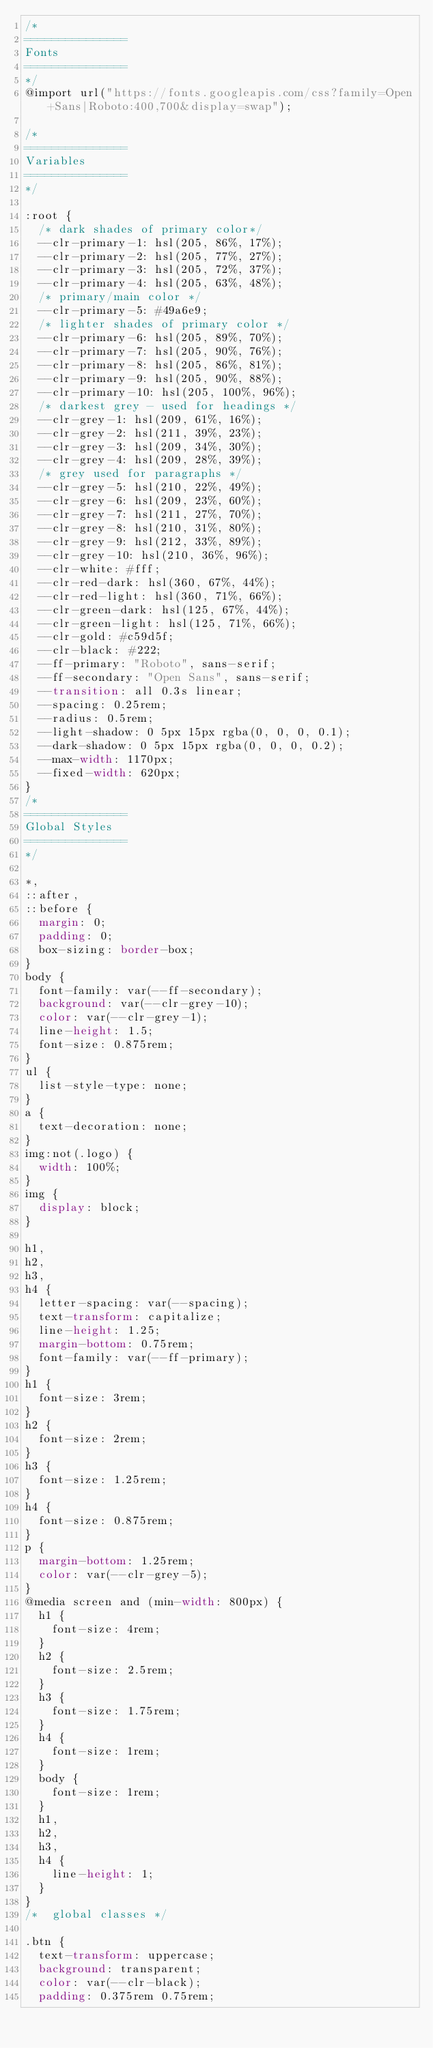Convert code to text. <code><loc_0><loc_0><loc_500><loc_500><_CSS_>/*
=============== 
Fonts
===============
*/
@import url("https://fonts.googleapis.com/css?family=Open+Sans|Roboto:400,700&display=swap");

/*
=============== 
Variables
===============
*/

:root {
  /* dark shades of primary color*/
  --clr-primary-1: hsl(205, 86%, 17%);
  --clr-primary-2: hsl(205, 77%, 27%);
  --clr-primary-3: hsl(205, 72%, 37%);
  --clr-primary-4: hsl(205, 63%, 48%);
  /* primary/main color */
  --clr-primary-5: #49a6e9;
  /* lighter shades of primary color */
  --clr-primary-6: hsl(205, 89%, 70%);
  --clr-primary-7: hsl(205, 90%, 76%);
  --clr-primary-8: hsl(205, 86%, 81%);
  --clr-primary-9: hsl(205, 90%, 88%);
  --clr-primary-10: hsl(205, 100%, 96%);
  /* darkest grey - used for headings */
  --clr-grey-1: hsl(209, 61%, 16%);
  --clr-grey-2: hsl(211, 39%, 23%);
  --clr-grey-3: hsl(209, 34%, 30%);
  --clr-grey-4: hsl(209, 28%, 39%);
  /* grey used for paragraphs */
  --clr-grey-5: hsl(210, 22%, 49%);
  --clr-grey-6: hsl(209, 23%, 60%);
  --clr-grey-7: hsl(211, 27%, 70%);
  --clr-grey-8: hsl(210, 31%, 80%);
  --clr-grey-9: hsl(212, 33%, 89%);
  --clr-grey-10: hsl(210, 36%, 96%);
  --clr-white: #fff;
  --clr-red-dark: hsl(360, 67%, 44%);
  --clr-red-light: hsl(360, 71%, 66%);
  --clr-green-dark: hsl(125, 67%, 44%);
  --clr-green-light: hsl(125, 71%, 66%);
  --clr-gold: #c59d5f;
  --clr-black: #222;
  --ff-primary: "Roboto", sans-serif;
  --ff-secondary: "Open Sans", sans-serif;
  --transition: all 0.3s linear;
  --spacing: 0.25rem;
  --radius: 0.5rem;
  --light-shadow: 0 5px 15px rgba(0, 0, 0, 0.1);
  --dark-shadow: 0 5px 15px rgba(0, 0, 0, 0.2);
  --max-width: 1170px;
  --fixed-width: 620px;
}
/*
=============== 
Global Styles
===============
*/

*,
::after,
::before {
  margin: 0;
  padding: 0;
  box-sizing: border-box;
}
body {
  font-family: var(--ff-secondary);
  background: var(--clr-grey-10);
  color: var(--clr-grey-1);
  line-height: 1.5;
  font-size: 0.875rem;
}
ul {
  list-style-type: none;
}
a {
  text-decoration: none;
}
img:not(.logo) {
  width: 100%;
}
img {
  display: block;
}

h1,
h2,
h3,
h4 {
  letter-spacing: var(--spacing);
  text-transform: capitalize;
  line-height: 1.25;
  margin-bottom: 0.75rem;
  font-family: var(--ff-primary);
}
h1 {
  font-size: 3rem;
}
h2 {
  font-size: 2rem;
}
h3 {
  font-size: 1.25rem;
}
h4 {
  font-size: 0.875rem;
}
p {
  margin-bottom: 1.25rem;
  color: var(--clr-grey-5);
}
@media screen and (min-width: 800px) {
  h1 {
    font-size: 4rem;
  }
  h2 {
    font-size: 2.5rem;
  }
  h3 {
    font-size: 1.75rem;
  }
  h4 {
    font-size: 1rem;
  }
  body {
    font-size: 1rem;
  }
  h1,
  h2,
  h3,
  h4 {
    line-height: 1;
  }
}
/*  global classes */

.btn {
  text-transform: uppercase;
  background: transparent;
  color: var(--clr-black);
  padding: 0.375rem 0.75rem;</code> 